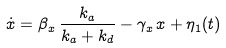<formula> <loc_0><loc_0><loc_500><loc_500>\dot { x } = \beta _ { x } \, \frac { k _ { a } } { k _ { a } + k _ { d } } - \gamma _ { x } \, x + \eta _ { 1 } ( t )</formula> 